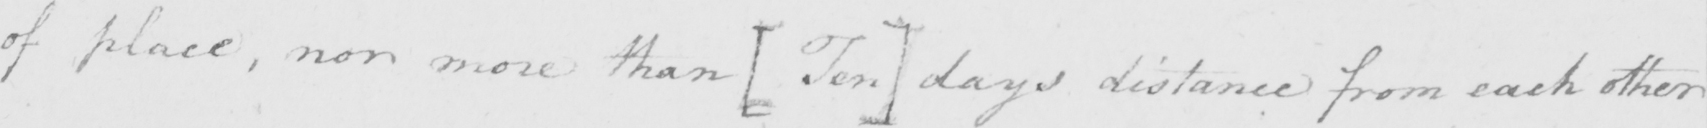Please provide the text content of this handwritten line. of place, nor more than [Ten] days distance from each other 